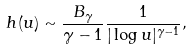Convert formula to latex. <formula><loc_0><loc_0><loc_500><loc_500>h ( u ) \sim \frac { B _ { \gamma } } { \gamma - 1 } \frac { 1 } { | \log u | ^ { \gamma - 1 } } ,</formula> 